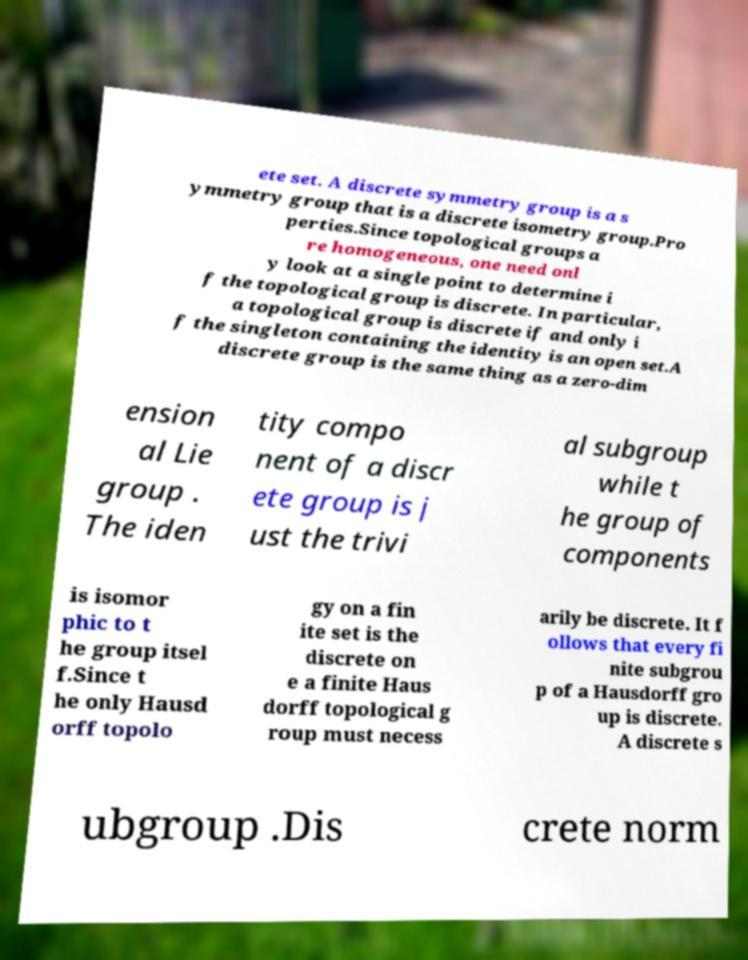Can you read and provide the text displayed in the image?This photo seems to have some interesting text. Can you extract and type it out for me? ete set. A discrete symmetry group is a s ymmetry group that is a discrete isometry group.Pro perties.Since topological groups a re homogeneous, one need onl y look at a single point to determine i f the topological group is discrete. In particular, a topological group is discrete if and only i f the singleton containing the identity is an open set.A discrete group is the same thing as a zero-dim ension al Lie group . The iden tity compo nent of a discr ete group is j ust the trivi al subgroup while t he group of components is isomor phic to t he group itsel f.Since t he only Hausd orff topolo gy on a fin ite set is the discrete on e a finite Haus dorff topological g roup must necess arily be discrete. It f ollows that every fi nite subgrou p of a Hausdorff gro up is discrete. A discrete s ubgroup .Dis crete norm 